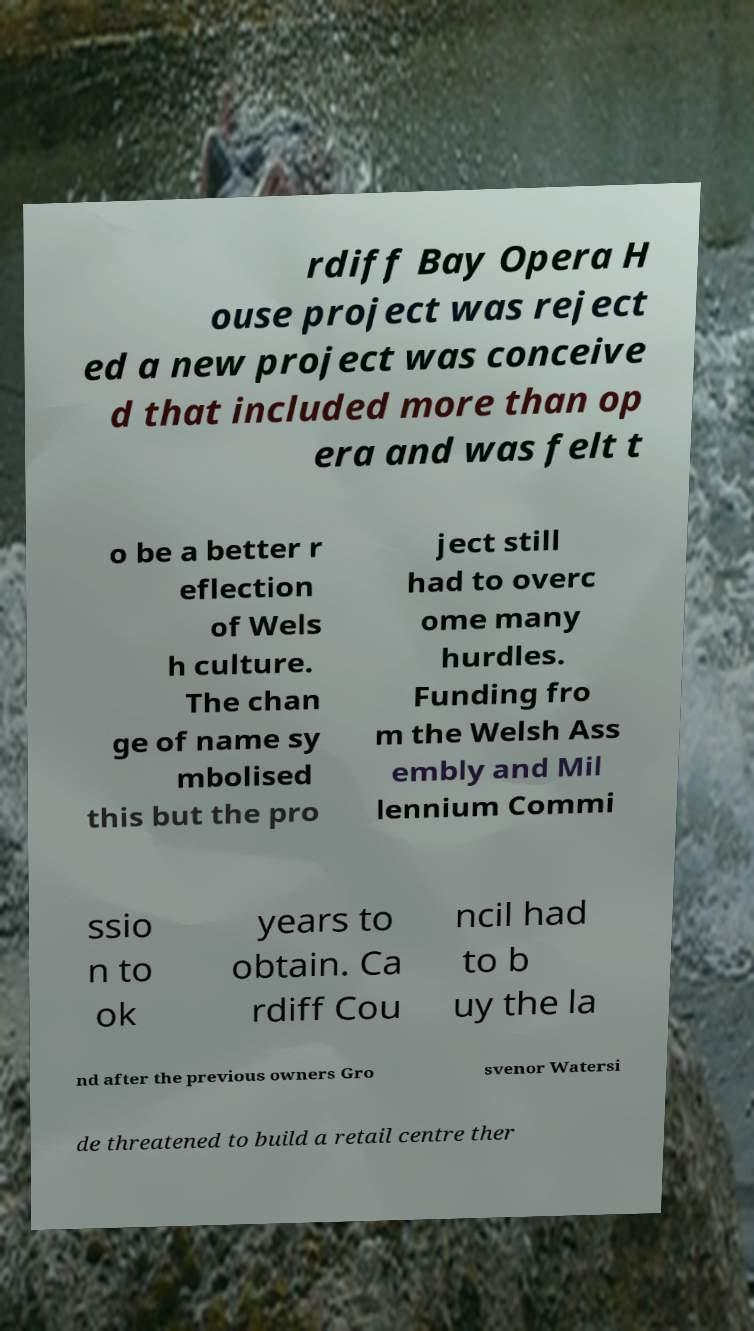I need the written content from this picture converted into text. Can you do that? rdiff Bay Opera H ouse project was reject ed a new project was conceive d that included more than op era and was felt t o be a better r eflection of Wels h culture. The chan ge of name sy mbolised this but the pro ject still had to overc ome many hurdles. Funding fro m the Welsh Ass embly and Mil lennium Commi ssio n to ok years to obtain. Ca rdiff Cou ncil had to b uy the la nd after the previous owners Gro svenor Watersi de threatened to build a retail centre ther 